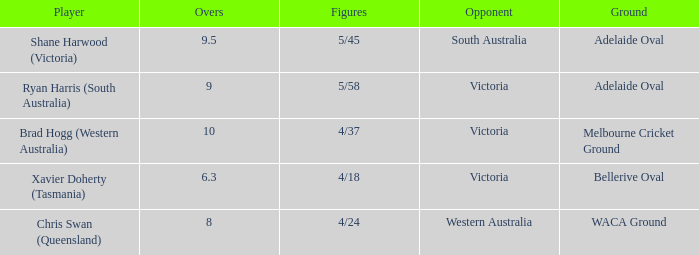What did Xavier Doherty (Tasmania) set as his highest Overs? 6.3. 